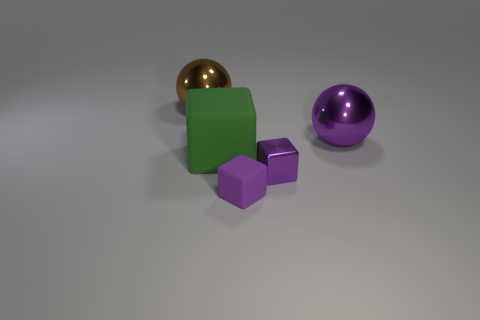Are there any tiny yellow objects made of the same material as the brown sphere?
Offer a terse response. No. The small thing that is the same color as the shiny block is what shape?
Provide a short and direct response. Cube. What is the color of the thing left of the big green matte cube?
Offer a very short reply. Brown. Are there the same number of big brown balls in front of the brown ball and tiny rubber cubes that are in front of the purple rubber object?
Ensure brevity in your answer.  Yes. What is the material of the large sphere in front of the ball left of the purple metallic sphere?
Provide a short and direct response. Metal. How many things are big purple shiny balls or metallic things that are behind the large green cube?
Provide a succinct answer. 2. The cube that is made of the same material as the brown object is what size?
Provide a short and direct response. Small. Are there more cubes that are behind the small shiny block than big spheres?
Give a very brief answer. No. What size is the object that is behind the large green object and on the left side of the metallic cube?
Give a very brief answer. Large. What material is the other small object that is the same shape as the small purple metal thing?
Provide a short and direct response. Rubber. 